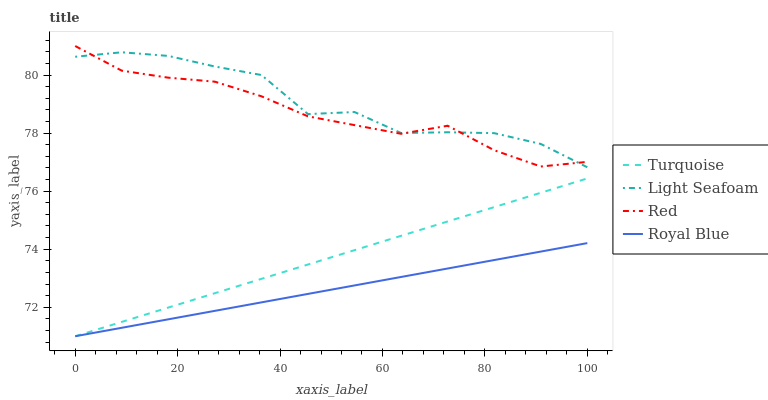Does Royal Blue have the minimum area under the curve?
Answer yes or no. Yes. Does Light Seafoam have the maximum area under the curve?
Answer yes or no. Yes. Does Turquoise have the minimum area under the curve?
Answer yes or no. No. Does Turquoise have the maximum area under the curve?
Answer yes or no. No. Is Turquoise the smoothest?
Answer yes or no. Yes. Is Light Seafoam the roughest?
Answer yes or no. Yes. Is Light Seafoam the smoothest?
Answer yes or no. No. Is Turquoise the roughest?
Answer yes or no. No. Does Royal Blue have the lowest value?
Answer yes or no. Yes. Does Light Seafoam have the lowest value?
Answer yes or no. No. Does Red have the highest value?
Answer yes or no. Yes. Does Turquoise have the highest value?
Answer yes or no. No. Is Turquoise less than Red?
Answer yes or no. Yes. Is Light Seafoam greater than Royal Blue?
Answer yes or no. Yes. Does Turquoise intersect Royal Blue?
Answer yes or no. Yes. Is Turquoise less than Royal Blue?
Answer yes or no. No. Is Turquoise greater than Royal Blue?
Answer yes or no. No. Does Turquoise intersect Red?
Answer yes or no. No. 